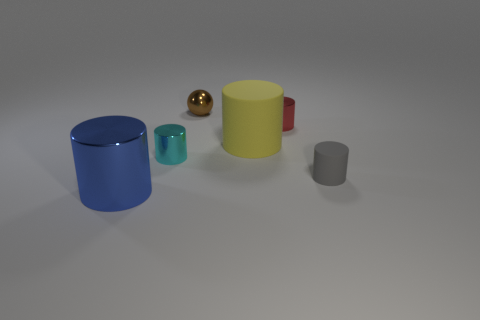Subtract all shiny cylinders. How many cylinders are left? 2 Subtract all red cylinders. How many cylinders are left? 4 Subtract 1 cylinders. How many cylinders are left? 4 Add 3 tiny brown balls. How many objects exist? 9 Subtract all balls. How many objects are left? 5 Subtract all purple cylinders. How many gray spheres are left? 0 Add 3 tiny shiny things. How many tiny shiny things are left? 6 Add 4 tiny shiny things. How many tiny shiny things exist? 7 Subtract 0 green cubes. How many objects are left? 6 Subtract all blue spheres. Subtract all green blocks. How many spheres are left? 1 